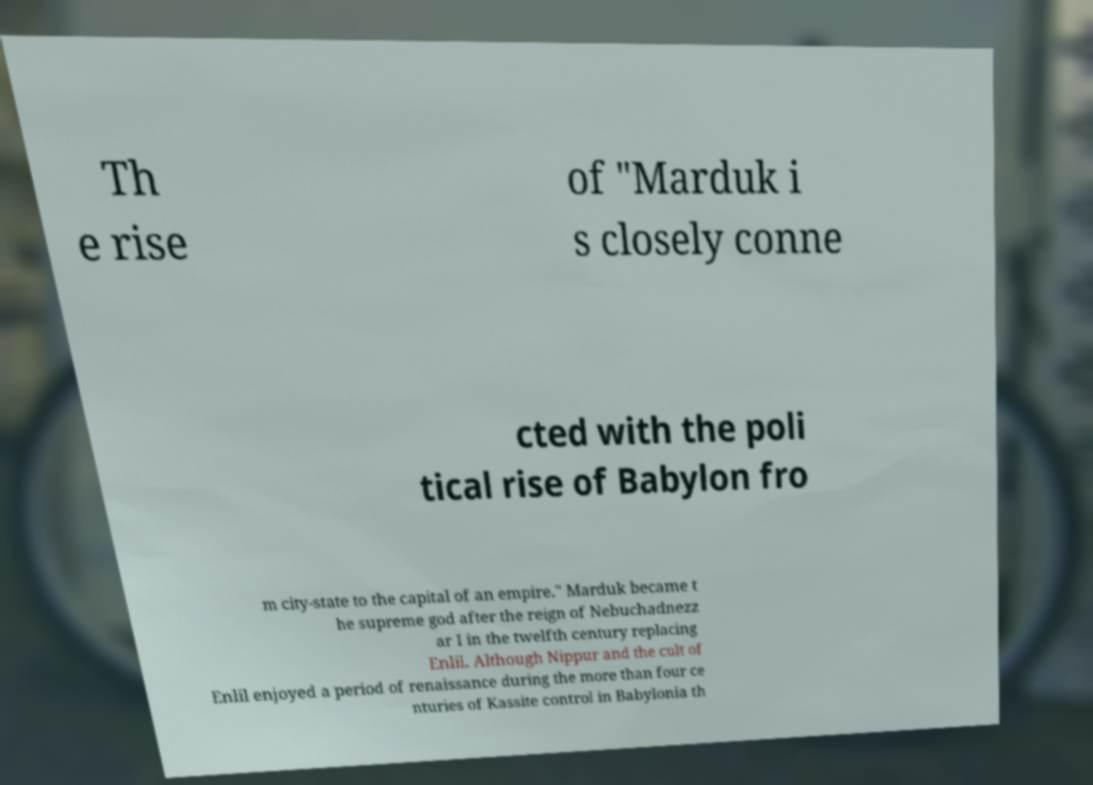Please identify and transcribe the text found in this image. Th e rise of "Marduk i s closely conne cted with the poli tical rise of Babylon fro m city-state to the capital of an empire." Marduk became t he supreme god after the reign of Nebuchadnezz ar I in the twelfth century replacing Enlil. Although Nippur and the cult of Enlil enjoyed a period of renaissance during the more than four ce nturies of Kassite control in Babylonia th 